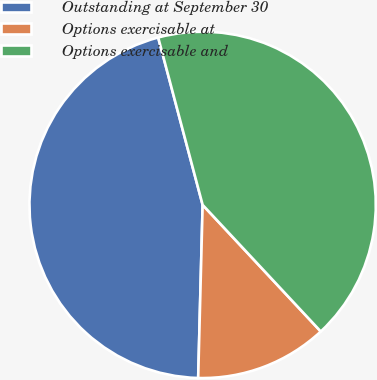Convert chart. <chart><loc_0><loc_0><loc_500><loc_500><pie_chart><fcel>Outstanding at September 30<fcel>Options exercisable at<fcel>Options exercisable and<nl><fcel>45.46%<fcel>12.36%<fcel>42.18%<nl></chart> 